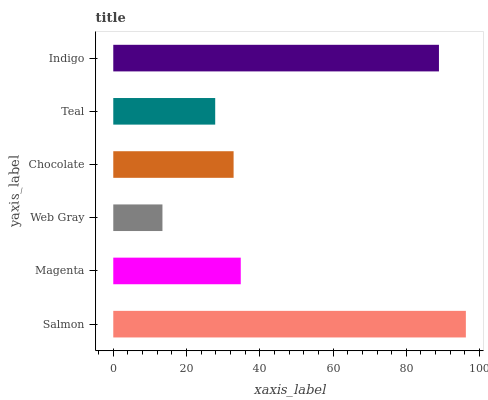Is Web Gray the minimum?
Answer yes or no. Yes. Is Salmon the maximum?
Answer yes or no. Yes. Is Magenta the minimum?
Answer yes or no. No. Is Magenta the maximum?
Answer yes or no. No. Is Salmon greater than Magenta?
Answer yes or no. Yes. Is Magenta less than Salmon?
Answer yes or no. Yes. Is Magenta greater than Salmon?
Answer yes or no. No. Is Salmon less than Magenta?
Answer yes or no. No. Is Magenta the high median?
Answer yes or no. Yes. Is Chocolate the low median?
Answer yes or no. Yes. Is Web Gray the high median?
Answer yes or no. No. Is Teal the low median?
Answer yes or no. No. 